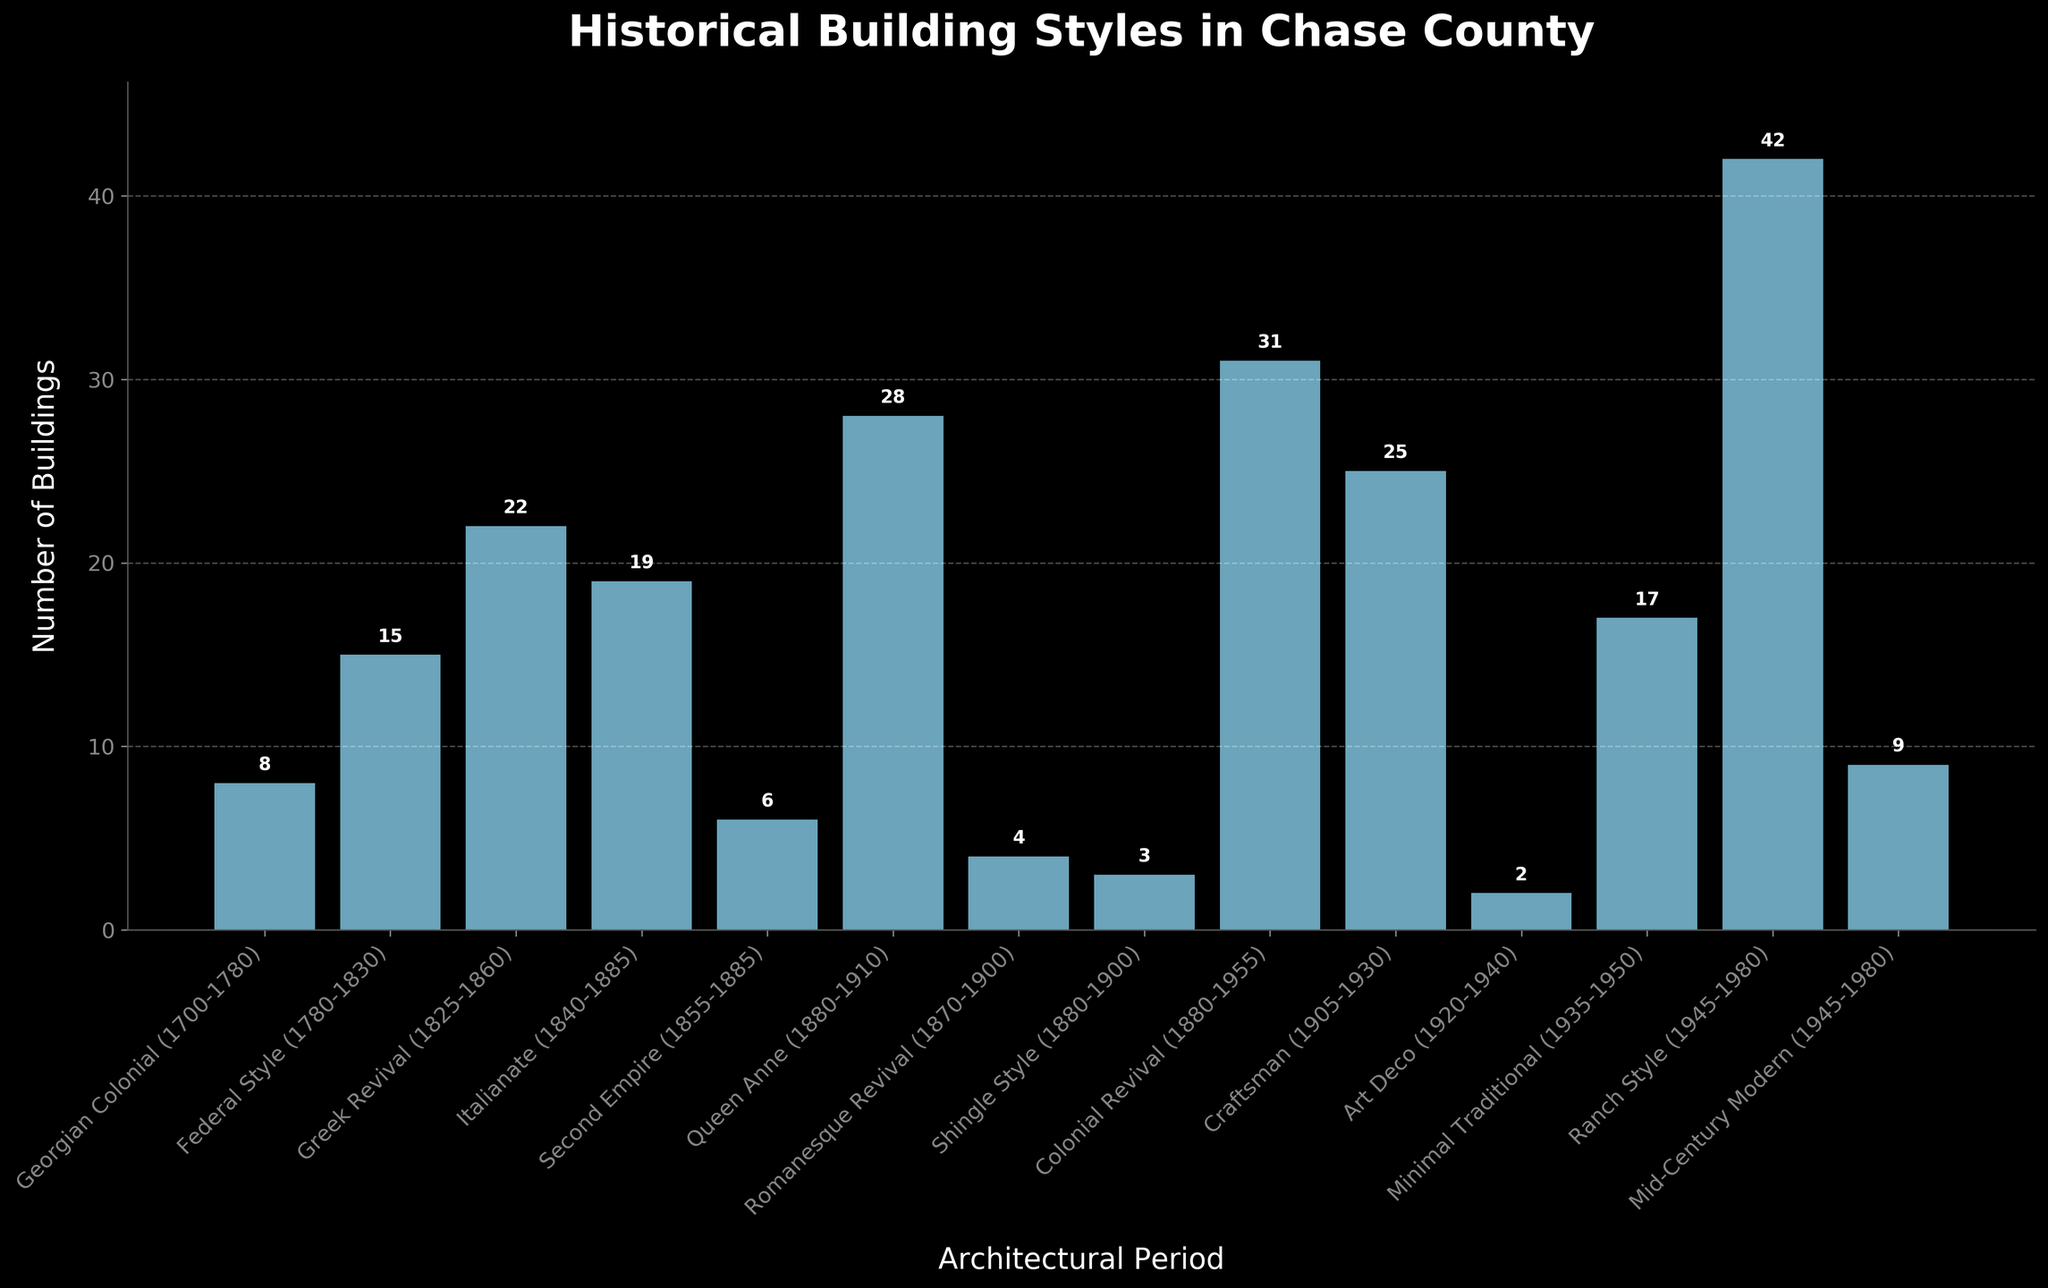What's the architectural period with the highest number of buildings? The bar representing the Ranch Style architectural period is the tallest in the plot, indicating it has the highest number of buildings. By checking the figure, we find it's 42 buildings.
Answer: Ranch Style Which architectural period has fewer buildings: Art Deco or Shingle Style? The bar for Art Deco is shorter compared to the bar for Shingle Style. Art Deco has 2 buildings, while Shingle Style has 3 buildings.
Answer: Art Deco What is the total number of buildings constructed during the 18th century? The 18th century includes Georgian Colonial (1700-1780) and Federal Style (1780-1830). Summing their building numbers: Georgian Colonial (8) + Federal Style (15) = 23.
Answer: 23 How many periods have more than 20 buildings? Counting the bars that are higher than the 20-mark on the y-axis, we find 4 periods: Greek Revival (22), Queen Anne (28), Colonial Revival (31), and Ranch Style (42).
Answer: 4 Which periods have fewer than 5 buildings? Checking the bars that are below the 5-mark on the y-axis, we see Romanesque Revival (4), Shingle Style (3), and Art Deco (2).
Answer: 3 How does the number of buildings from the Georgian Colonial period compare to the Federal Style period? The bar for the Georgian Colonial period is shorter compared to the Federal Style period. Georgian Colonial has 8 buildings, while Federal Style has 15 buildings.
Answer: Georgian Colonial has fewer buildings than Federal Style What is the difference in the number of buildings between Ranch Style and Craftsman periods? Ranch Style has 42 buildings and Craftsman has 25 buildings. The difference is 42 - 25 = 17.
Answer: 17 List the periods ordered from the fewest buildings to the most. By comparing the height of the bars from shortest to tallest, the order is: Art Deco (2), Shingle Style (3), Romanesque Revival (4), Second Empire (6), Georgian Colonial (8), Mid-Century Modern (9), Federal Style (15), Minimal Traditional (17), Italianate (19), Greek Revival (22), Craftsman (25), Queen Anne (28), Colonial Revival (31), Ranch Style (42).
Answer: Art Deco, Shingle Style, Romanesque Revival, Second Empire, Georgian Colonial, Mid-Century Modern, Federal Style, Minimal Traditional, Italianate, Greek Revival, Craftsman, Queen Anne, Colonial Revival, Ranch Style What is the combined number of buildings in the Queen Anne and Colonial Revival periods? Adding the buildings from Queen Anne (28) and Colonial Revival (31) gives 28 + 31 = 59.
Answer: 59 Which periods fall within the period range of 1855 to 1950? Examining the periods specified: Second Empire (1855-1885), Queen Anne (1880-1910), Romanesque Revival (1870-1900), Shingle Style (1880-1900), Colonial Revival (1880-1955), Craftsman (1905-1930), Art Deco (1920-1940), Minimal Traditional (1935-1950).
Answer: Second Empire, Queen Anne, Romanesque Revival, Shingle Style, Colonial Revival, Craftsman, Art Deco, Minimal Traditional 